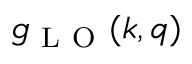<formula> <loc_0><loc_0><loc_500><loc_500>g _ { L O } ( k , q )</formula> 